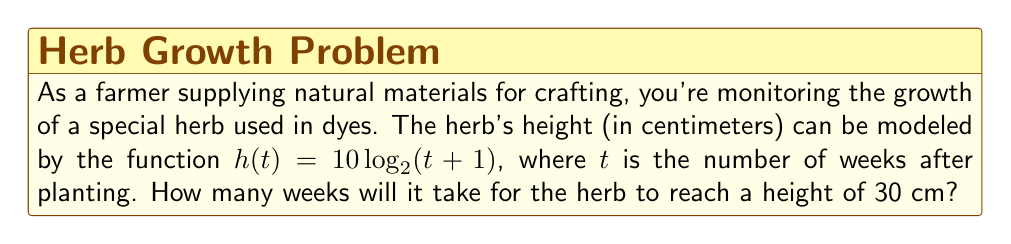Can you answer this question? Let's approach this step-by-step:

1) We're given the growth function: $h(t) = 10 \log_2(t + 1)$

2) We want to find $t$ when $h(t) = 30$. So, let's set up the equation:
   
   $30 = 10 \log_2(t + 1)$

3) Divide both sides by 10:
   
   $3 = \log_2(t + 1)$

4) To solve for $t$, we need to apply the inverse function (exponential) to both sides:
   
   $2^3 = t + 1$

5) Simplify the left side:
   
   $8 = t + 1$

6) Subtract 1 from both sides:
   
   $7 = t$

Therefore, it will take 7 weeks for the herb to reach a height of 30 cm.
Answer: 7 weeks 